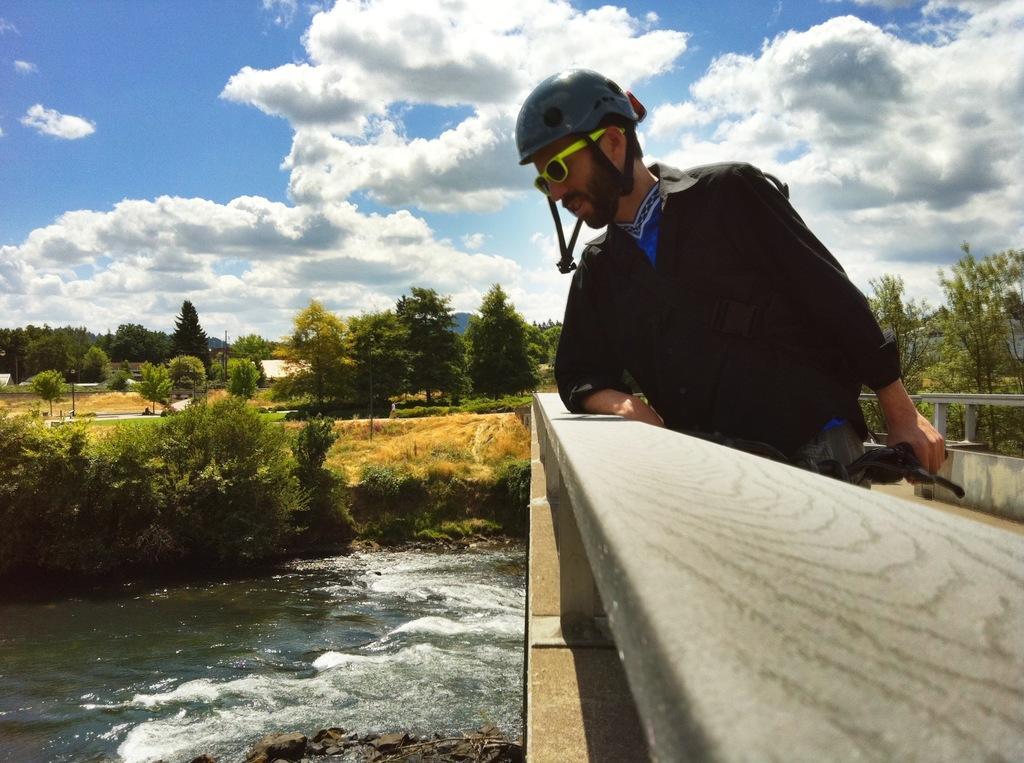Please provide a concise description of this image. This picture is clicked outside. On the right we can see a man wearing shirt, helmet, holding an object and standing. On the left we can see a water body. On the right we can see a bridge like object. In the center we can see the plants, grass, trees and some objects and the metal rods. In the background we can see the sky with the clouds and we can see the trees and some other objects. 